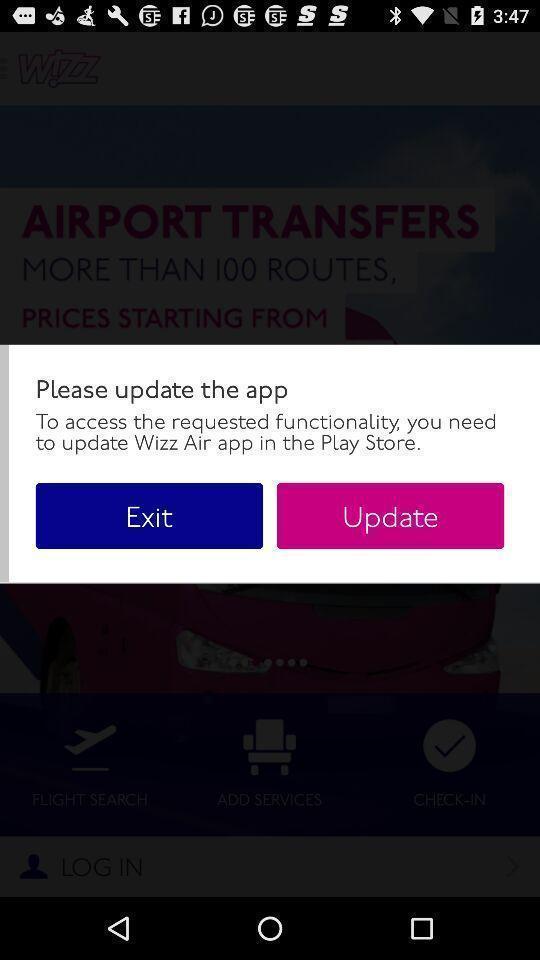Provide a textual representation of this image. Pop up page for update. 